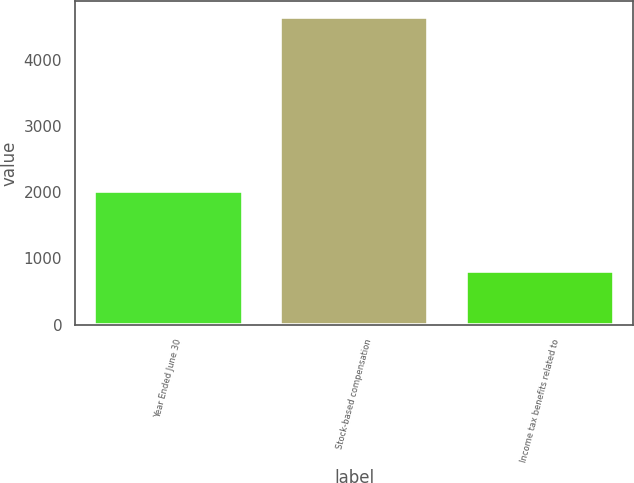Convert chart. <chart><loc_0><loc_0><loc_500><loc_500><bar_chart><fcel>Year Ended June 30<fcel>Stock-based compensation<fcel>Income tax benefits related to<nl><fcel>2019<fcel>4652<fcel>816<nl></chart> 